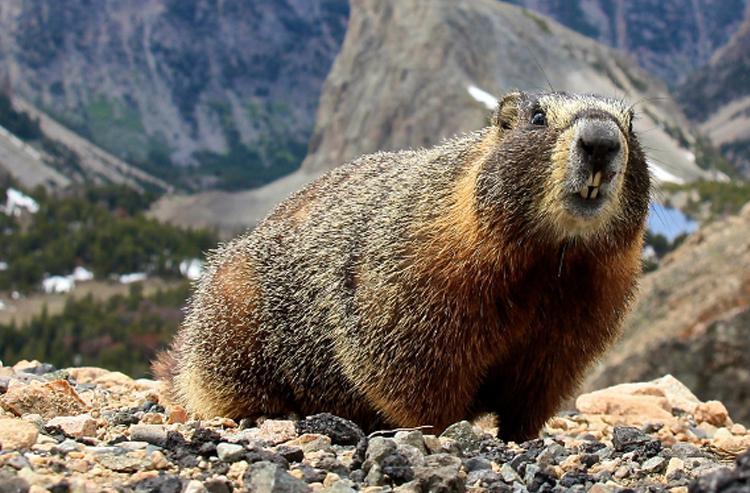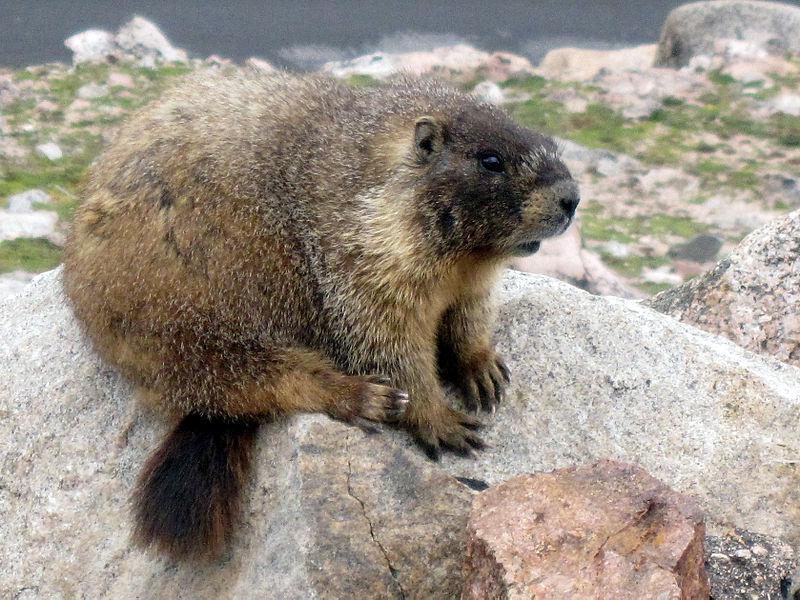The first image is the image on the left, the second image is the image on the right. Examine the images to the left and right. Is the description "Both marmots are facing toward the right" accurate? Answer yes or no. Yes. The first image is the image on the left, the second image is the image on the right. For the images shown, is this caption "Each image shows just one groundhog-type animal, which is facing rightward." true? Answer yes or no. Yes. 